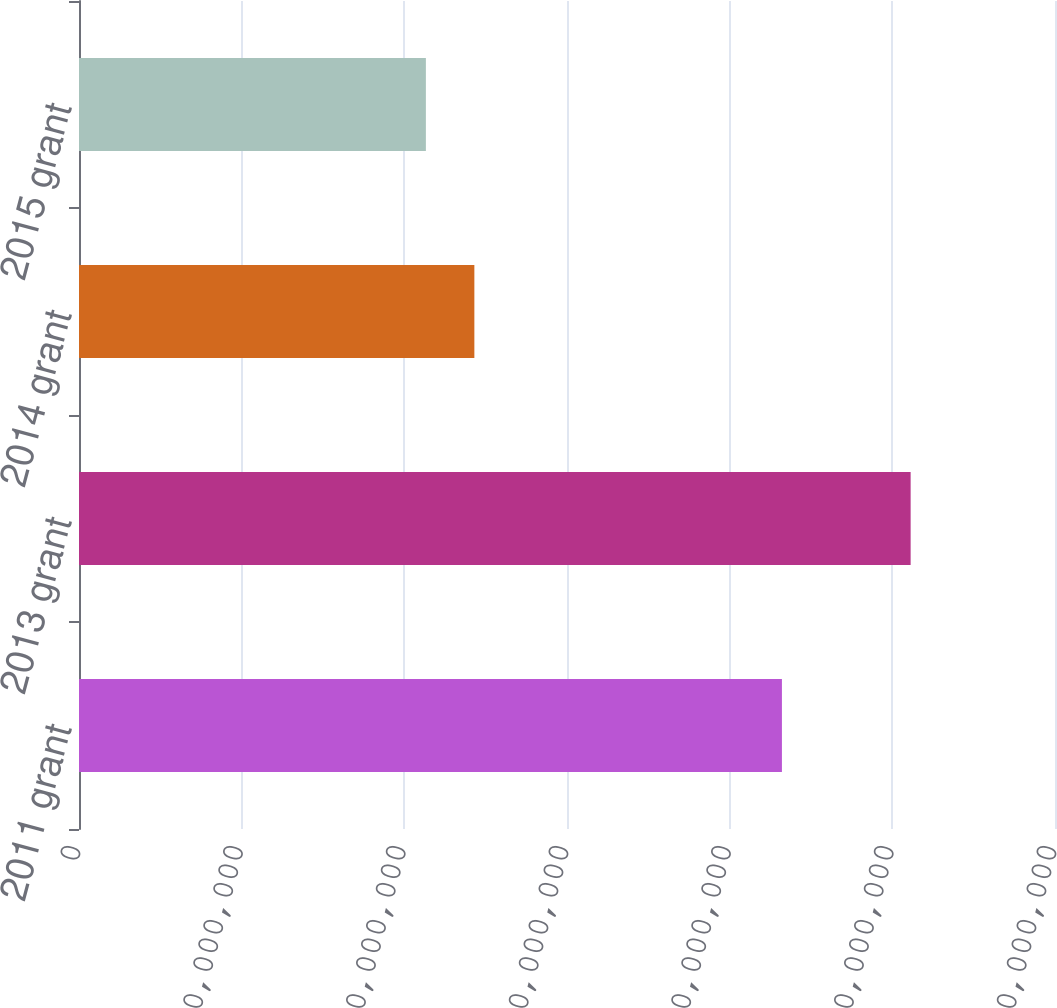<chart> <loc_0><loc_0><loc_500><loc_500><bar_chart><fcel>2011 grant<fcel>2013 grant<fcel>2014 grant<fcel>2015 grant<nl><fcel>4.32125e+07<fcel>5.1125e+07<fcel>2.4305e+07<fcel>2.1325e+07<nl></chart> 